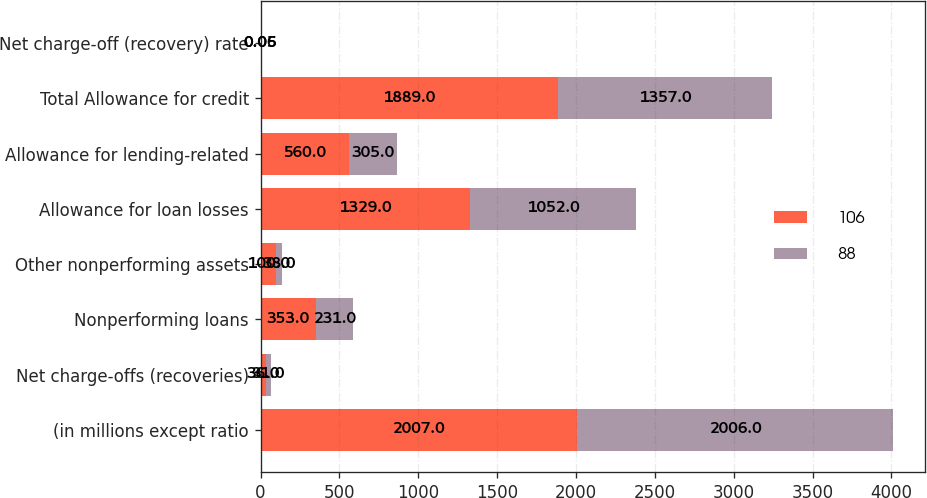<chart> <loc_0><loc_0><loc_500><loc_500><stacked_bar_chart><ecel><fcel>(in millions except ratio<fcel>Net charge-offs (recoveries)<fcel>Nonperforming loans<fcel>Other nonperforming assets<fcel>Allowance for loan losses<fcel>Allowance for lending-related<fcel>Total Allowance for credit<fcel>Net charge-off (recovery) rate<nl><fcel>106<fcel>2007<fcel>36<fcel>353<fcel>100<fcel>1329<fcel>560<fcel>1889<fcel>0.06<nl><fcel>88<fcel>2006<fcel>31<fcel>231<fcel>38<fcel>1052<fcel>305<fcel>1357<fcel>0.05<nl></chart> 